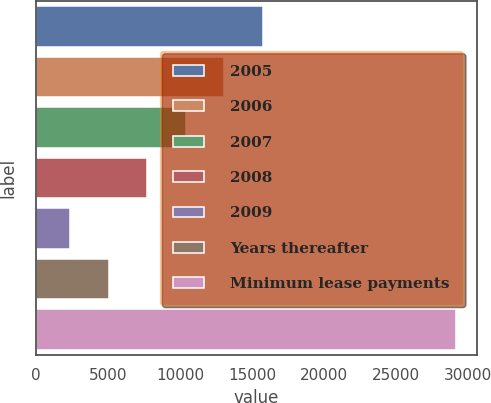Convert chart to OTSL. <chart><loc_0><loc_0><loc_500><loc_500><bar_chart><fcel>2005<fcel>2006<fcel>2007<fcel>2008<fcel>2009<fcel>Years thereafter<fcel>Minimum lease payments<nl><fcel>15746<fcel>13066<fcel>10386<fcel>7706<fcel>2346<fcel>5026<fcel>29146<nl></chart> 